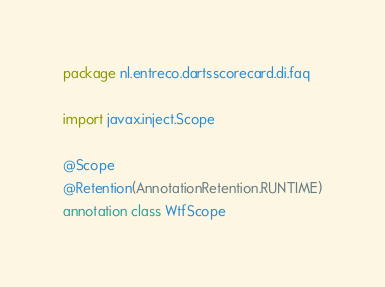<code> <loc_0><loc_0><loc_500><loc_500><_Kotlin_>package nl.entreco.dartsscorecard.di.faq

import javax.inject.Scope

@Scope
@Retention(AnnotationRetention.RUNTIME)
annotation class WtfScope</code> 